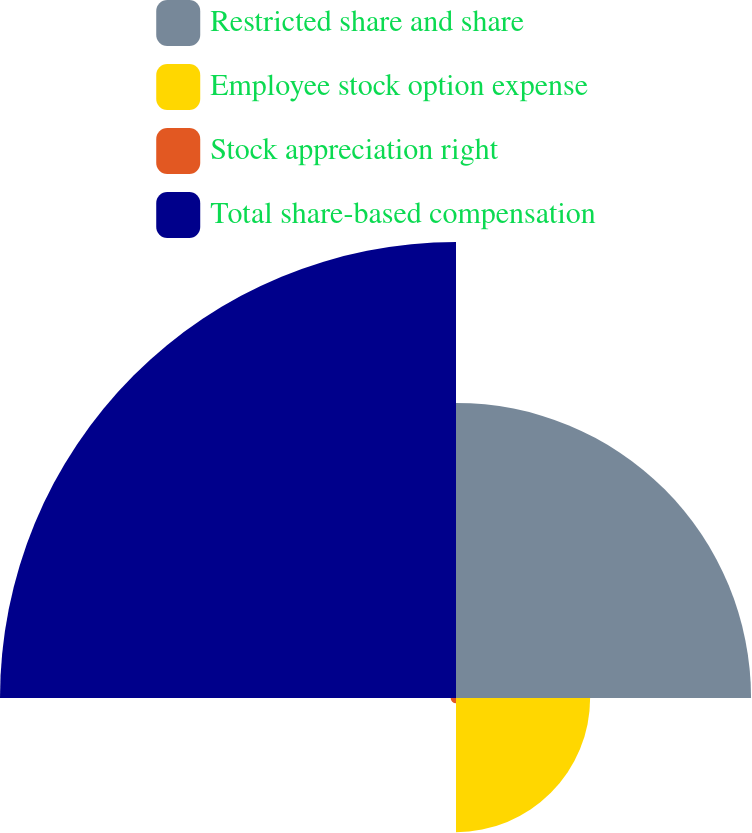<chart> <loc_0><loc_0><loc_500><loc_500><pie_chart><fcel>Restricted share and share<fcel>Employee stock option expense<fcel>Stock appreciation right<fcel>Total share-based compensation<nl><fcel>33.13%<fcel>15.06%<fcel>0.6%<fcel>51.2%<nl></chart> 